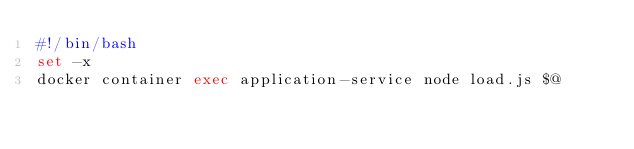<code> <loc_0><loc_0><loc_500><loc_500><_Bash_>#!/bin/bash
set -x
docker container exec application-service node load.js $@</code> 